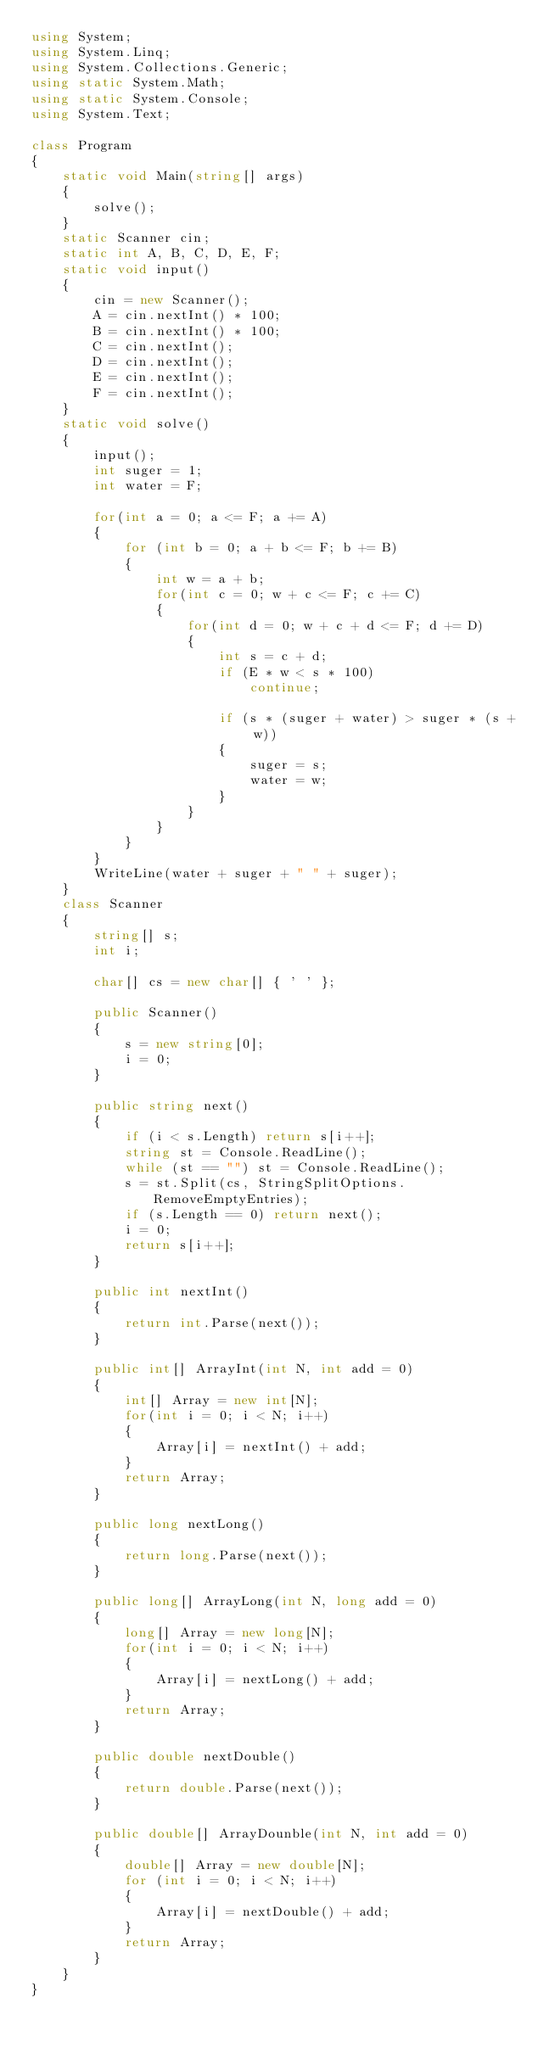Convert code to text. <code><loc_0><loc_0><loc_500><loc_500><_C#_>using System;
using System.Linq;
using System.Collections.Generic;
using static System.Math;
using static System.Console;
using System.Text;

class Program
{
    static void Main(string[] args)
    {
        solve();
    }
    static Scanner cin;
    static int A, B, C, D, E, F;
    static void input()
    {
        cin = new Scanner();
        A = cin.nextInt() * 100;
        B = cin.nextInt() * 100;
        C = cin.nextInt();
        D = cin.nextInt();
        E = cin.nextInt();
        F = cin.nextInt();
    }
    static void solve()
    {
        input();
        int suger = 1;
        int water = F;

        for(int a = 0; a <= F; a += A)
        {
            for (int b = 0; a + b <= F; b += B)
            {
                int w = a + b;
                for(int c = 0; w + c <= F; c += C)
                {
                    for(int d = 0; w + c + d <= F; d += D)
                    {
                        int s = c + d;
                        if (E * w < s * 100)
                            continue;

                        if (s * (suger + water) > suger * (s + w))
                        {
                            suger = s;
                            water = w;
                        }
                    }
                }
            }
        }
        WriteLine(water + suger + " " + suger);
    }
    class Scanner
    {
        string[] s;
        int i;

        char[] cs = new char[] { ' ' };

        public Scanner()
        {
            s = new string[0];
            i = 0;
        }
        
        public string next()
        {
            if (i < s.Length) return s[i++];
            string st = Console.ReadLine();
            while (st == "") st = Console.ReadLine();
            s = st.Split(cs, StringSplitOptions.RemoveEmptyEntries);
            if (s.Length == 0) return next();
            i = 0;
            return s[i++];
        }

        public int nextInt()
        {
            return int.Parse(next());
        }

        public int[] ArrayInt(int N, int add = 0)
        {
            int[] Array = new int[N];
            for(int i = 0; i < N; i++)
            {
                Array[i] = nextInt() + add;
            }
            return Array;
        }

        public long nextLong()
        {
            return long.Parse(next());
        }

        public long[] ArrayLong(int N, long add = 0)
        {
            long[] Array = new long[N];
            for(int i = 0; i < N; i++)
            {
                Array[i] = nextLong() + add;
            }
            return Array;
        }

        public double nextDouble()
        {
            return double.Parse(next());
        }

        public double[] ArrayDounble(int N, int add = 0)
        {
            double[] Array = new double[N];
            for (int i = 0; i < N; i++)
            {
                Array[i] = nextDouble() + add;
            }
            return Array;
        }
    }
}</code> 